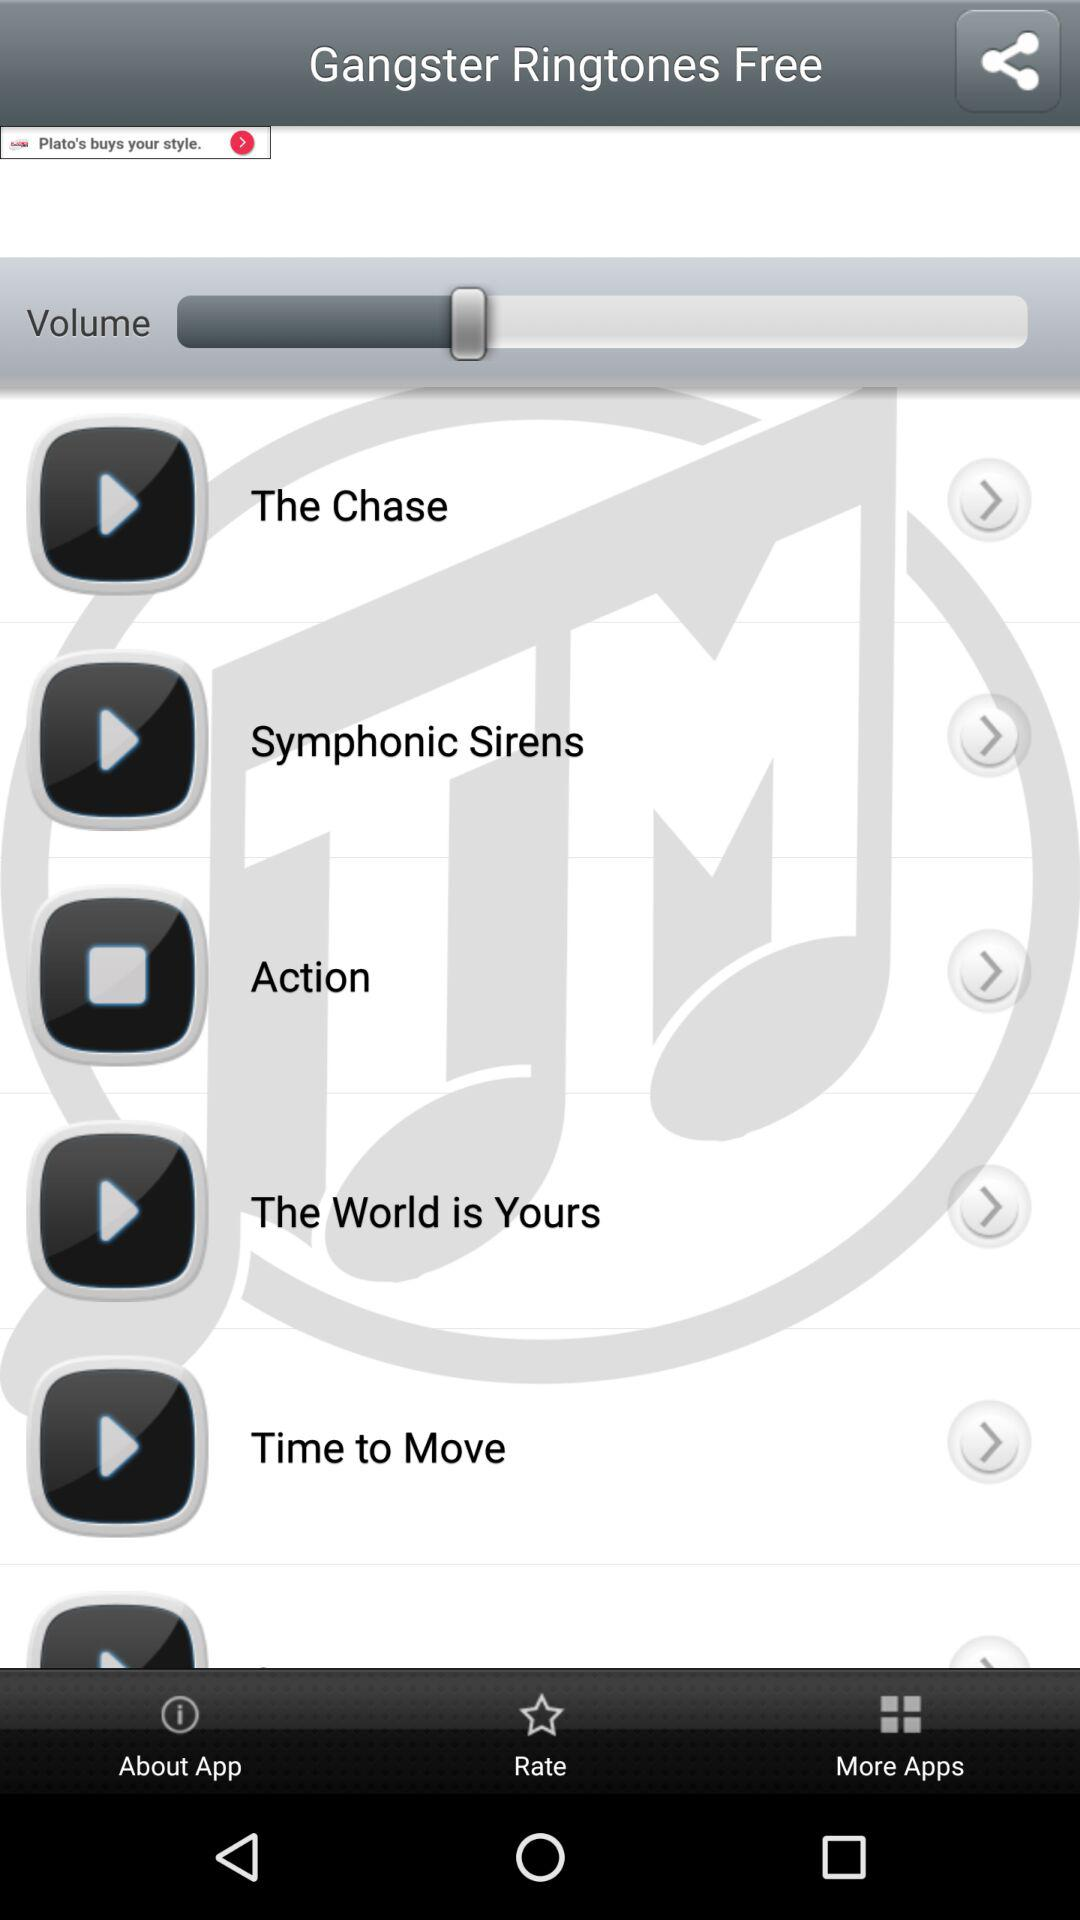What is the application name? The application name is "Gangster Ringtones Free". 